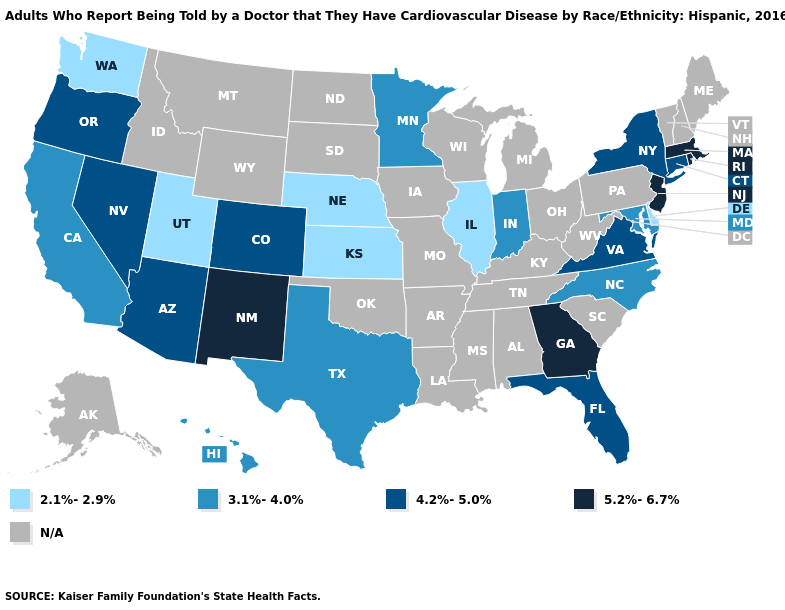Among the states that border Iowa , which have the lowest value?
Give a very brief answer. Illinois, Nebraska. Name the states that have a value in the range 4.2%-5.0%?
Be succinct. Arizona, Colorado, Connecticut, Florida, Nevada, New York, Oregon, Virginia. What is the lowest value in the MidWest?
Answer briefly. 2.1%-2.9%. Name the states that have a value in the range N/A?
Write a very short answer. Alabama, Alaska, Arkansas, Idaho, Iowa, Kentucky, Louisiana, Maine, Michigan, Mississippi, Missouri, Montana, New Hampshire, North Dakota, Ohio, Oklahoma, Pennsylvania, South Carolina, South Dakota, Tennessee, Vermont, West Virginia, Wisconsin, Wyoming. Name the states that have a value in the range N/A?
Short answer required. Alabama, Alaska, Arkansas, Idaho, Iowa, Kentucky, Louisiana, Maine, Michigan, Mississippi, Missouri, Montana, New Hampshire, North Dakota, Ohio, Oklahoma, Pennsylvania, South Carolina, South Dakota, Tennessee, Vermont, West Virginia, Wisconsin, Wyoming. Which states hav the highest value in the West?
Quick response, please. New Mexico. What is the lowest value in the USA?
Answer briefly. 2.1%-2.9%. Does Connecticut have the highest value in the Northeast?
Short answer required. No. What is the highest value in the South ?
Give a very brief answer. 5.2%-6.7%. What is the value of Indiana?
Quick response, please. 3.1%-4.0%. Name the states that have a value in the range 2.1%-2.9%?
Concise answer only. Delaware, Illinois, Kansas, Nebraska, Utah, Washington. What is the value of Nebraska?
Answer briefly. 2.1%-2.9%. Which states have the lowest value in the USA?
Short answer required. Delaware, Illinois, Kansas, Nebraska, Utah, Washington. Name the states that have a value in the range 2.1%-2.9%?
Keep it brief. Delaware, Illinois, Kansas, Nebraska, Utah, Washington. 